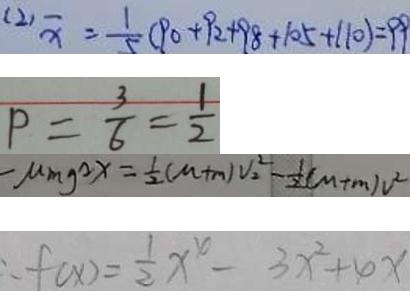Convert formula to latex. <formula><loc_0><loc_0><loc_500><loc_500>( 2 ) \overline { x } = \frac { 1 } { 5 } ( 9 0 + 9 2 + 9 8 + 1 0 5 + 1 1 0 ) = 9 9 
 P = \frac { 3 } { 6 } = \frac { 1 } { 2 } 
 - M m g ^ { 2 } x = \frac { 1 } { 2 } ( M + m ) V _ { 2 } ^ { 2 } - \frac { 1 } { 2 } ( M + m ) v ^ { 2 } 
 \therefore f ( x ) = \frac { 1 } { 2 } x ^ { 4 } - 3 x ^ { 2 } + 4 x</formula> 